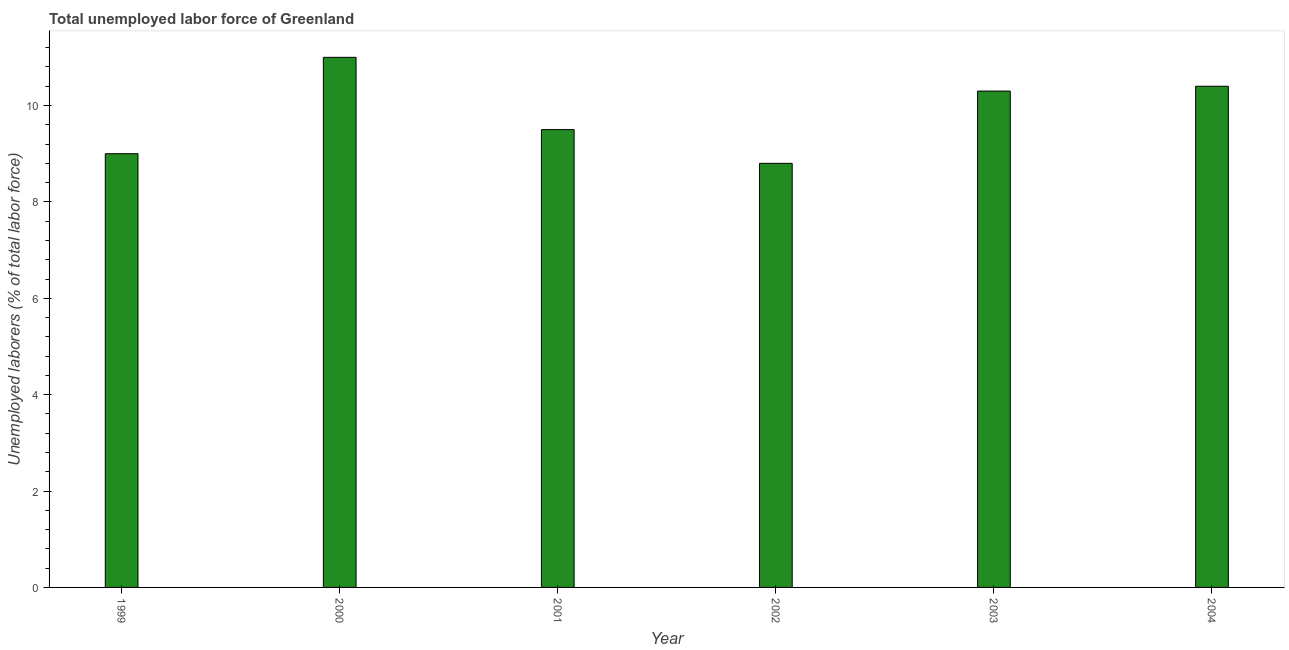Does the graph contain any zero values?
Keep it short and to the point. No. What is the title of the graph?
Provide a short and direct response. Total unemployed labor force of Greenland. What is the label or title of the Y-axis?
Provide a succinct answer. Unemployed laborers (% of total labor force). What is the total unemployed labour force in 2000?
Provide a succinct answer. 11. Across all years, what is the minimum total unemployed labour force?
Your answer should be very brief. 8.8. In which year was the total unemployed labour force maximum?
Keep it short and to the point. 2000. In which year was the total unemployed labour force minimum?
Offer a very short reply. 2002. What is the sum of the total unemployed labour force?
Provide a succinct answer. 59. What is the average total unemployed labour force per year?
Your answer should be compact. 9.83. What is the median total unemployed labour force?
Keep it short and to the point. 9.9. In how many years, is the total unemployed labour force greater than 6 %?
Keep it short and to the point. 6. Do a majority of the years between 1999 and 2003 (inclusive) have total unemployed labour force greater than 5.6 %?
Your response must be concise. Yes. What is the ratio of the total unemployed labour force in 2000 to that in 2003?
Your answer should be compact. 1.07. Is the difference between the total unemployed labour force in 1999 and 2000 greater than the difference between any two years?
Offer a terse response. No. What is the difference between the highest and the second highest total unemployed labour force?
Your answer should be very brief. 0.6. What is the difference between the highest and the lowest total unemployed labour force?
Give a very brief answer. 2.2. What is the difference between two consecutive major ticks on the Y-axis?
Make the answer very short. 2. Are the values on the major ticks of Y-axis written in scientific E-notation?
Provide a short and direct response. No. What is the Unemployed laborers (% of total labor force) of 1999?
Give a very brief answer. 9. What is the Unemployed laborers (% of total labor force) in 2001?
Your answer should be very brief. 9.5. What is the Unemployed laborers (% of total labor force) in 2002?
Offer a very short reply. 8.8. What is the Unemployed laborers (% of total labor force) of 2003?
Give a very brief answer. 10.3. What is the Unemployed laborers (% of total labor force) of 2004?
Your response must be concise. 10.4. What is the difference between the Unemployed laborers (% of total labor force) in 1999 and 2000?
Give a very brief answer. -2. What is the difference between the Unemployed laborers (% of total labor force) in 1999 and 2003?
Provide a succinct answer. -1.3. What is the difference between the Unemployed laborers (% of total labor force) in 1999 and 2004?
Provide a short and direct response. -1.4. What is the difference between the Unemployed laborers (% of total labor force) in 2000 and 2002?
Ensure brevity in your answer.  2.2. What is the difference between the Unemployed laborers (% of total labor force) in 2000 and 2003?
Your response must be concise. 0.7. What is the difference between the Unemployed laborers (% of total labor force) in 2003 and 2004?
Offer a terse response. -0.1. What is the ratio of the Unemployed laborers (% of total labor force) in 1999 to that in 2000?
Make the answer very short. 0.82. What is the ratio of the Unemployed laborers (% of total labor force) in 1999 to that in 2001?
Your response must be concise. 0.95. What is the ratio of the Unemployed laborers (% of total labor force) in 1999 to that in 2003?
Ensure brevity in your answer.  0.87. What is the ratio of the Unemployed laborers (% of total labor force) in 1999 to that in 2004?
Your answer should be compact. 0.86. What is the ratio of the Unemployed laborers (% of total labor force) in 2000 to that in 2001?
Offer a terse response. 1.16. What is the ratio of the Unemployed laborers (% of total labor force) in 2000 to that in 2002?
Your response must be concise. 1.25. What is the ratio of the Unemployed laborers (% of total labor force) in 2000 to that in 2003?
Offer a terse response. 1.07. What is the ratio of the Unemployed laborers (% of total labor force) in 2000 to that in 2004?
Provide a succinct answer. 1.06. What is the ratio of the Unemployed laborers (% of total labor force) in 2001 to that in 2003?
Provide a succinct answer. 0.92. What is the ratio of the Unemployed laborers (% of total labor force) in 2001 to that in 2004?
Offer a terse response. 0.91. What is the ratio of the Unemployed laborers (% of total labor force) in 2002 to that in 2003?
Ensure brevity in your answer.  0.85. What is the ratio of the Unemployed laborers (% of total labor force) in 2002 to that in 2004?
Provide a short and direct response. 0.85. What is the ratio of the Unemployed laborers (% of total labor force) in 2003 to that in 2004?
Provide a succinct answer. 0.99. 